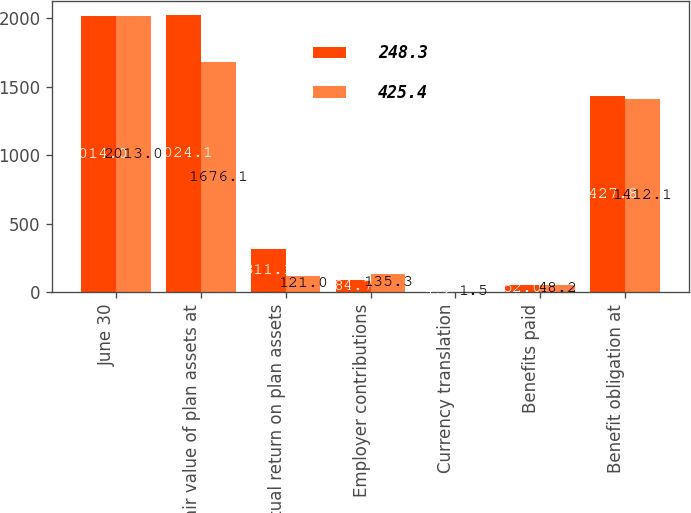Convert chart. <chart><loc_0><loc_0><loc_500><loc_500><stacked_bar_chart><ecel><fcel>June 30<fcel>Fair value of plan assets at<fcel>Actual return on plan assets<fcel>Employer contributions<fcel>Currency translation<fcel>Benefits paid<fcel>Benefit obligation at<nl><fcel>248.3<fcel>2014<fcel>2024.1<fcel>311.1<fcel>84.7<fcel>4.2<fcel>52<fcel>1427.8<nl><fcel>425.4<fcel>2013<fcel>1676.1<fcel>121<fcel>135.3<fcel>1.5<fcel>48.2<fcel>1412.1<nl></chart> 